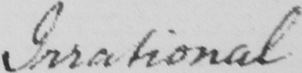What text is written in this handwritten line? Irrational 